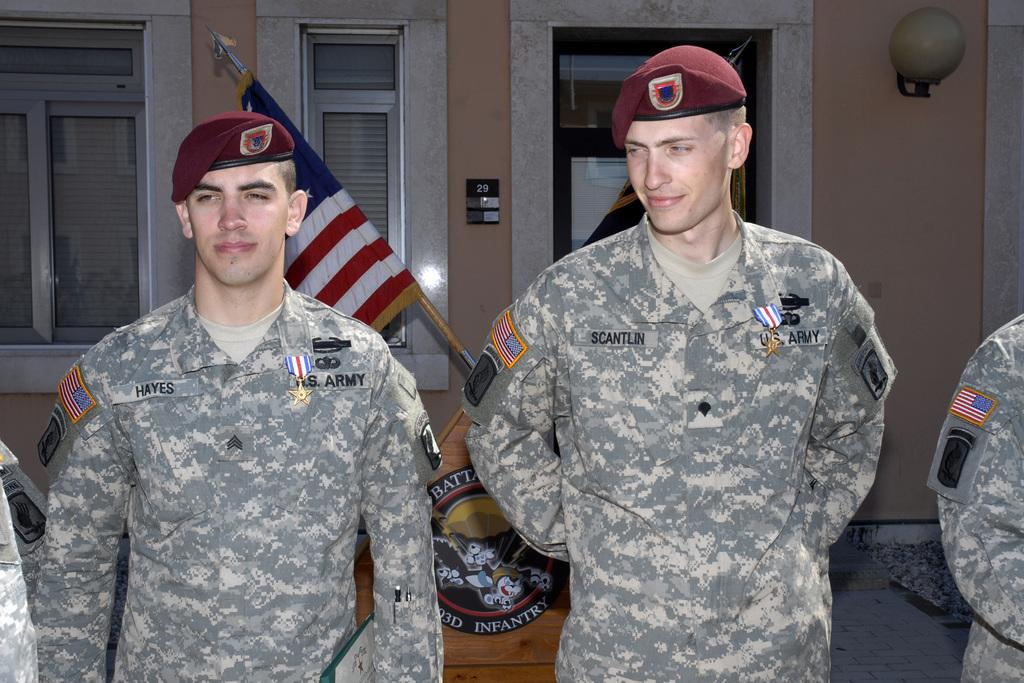Provide a one-sentence caption for the provided image. Two U.S. Army soldiers stand next to each other. 